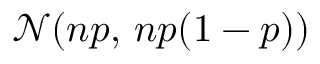<formula> <loc_0><loc_0><loc_500><loc_500>{ \mathcal { N } } ( n p , \, n p ( 1 - p ) )</formula> 